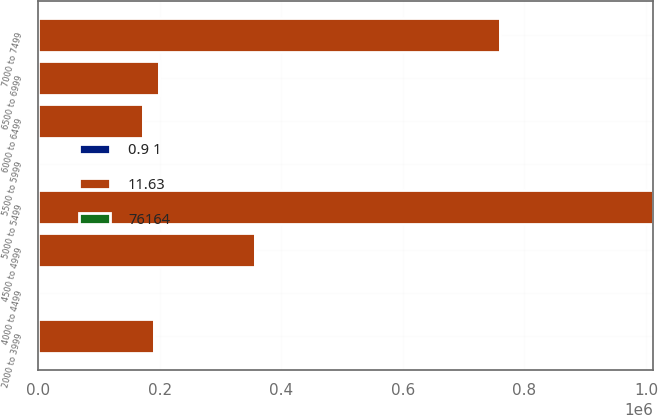Convert chart. <chart><loc_0><loc_0><loc_500><loc_500><stacked_bar_chart><ecel><fcel>2000 to 3999<fcel>4000 to 4499<fcel>4500 to 4999<fcel>5000 to 5499<fcel>5500 to 5999<fcel>6000 to 6499<fcel>6500 to 6999<fcel>7000 to 7499<nl><fcel>11.63<fcel>190986<fcel>51.01<fcel>356590<fcel>1.01138e+06<fcel>51.01<fcel>172390<fcel>198253<fcel>759814<nl><fcel>0.9 1<fcel>27.44<fcel>42.23<fcel>48.3<fcel>53.72<fcel>56.92<fcel>61.51<fcel>67.3<fcel>70.86<nl><fcel>76164<fcel>2.2<fcel>2.6<fcel>4.6<fcel>2.4<fcel>4.5<fcel>2.7<fcel>6.4<fcel>5.5<nl></chart> 